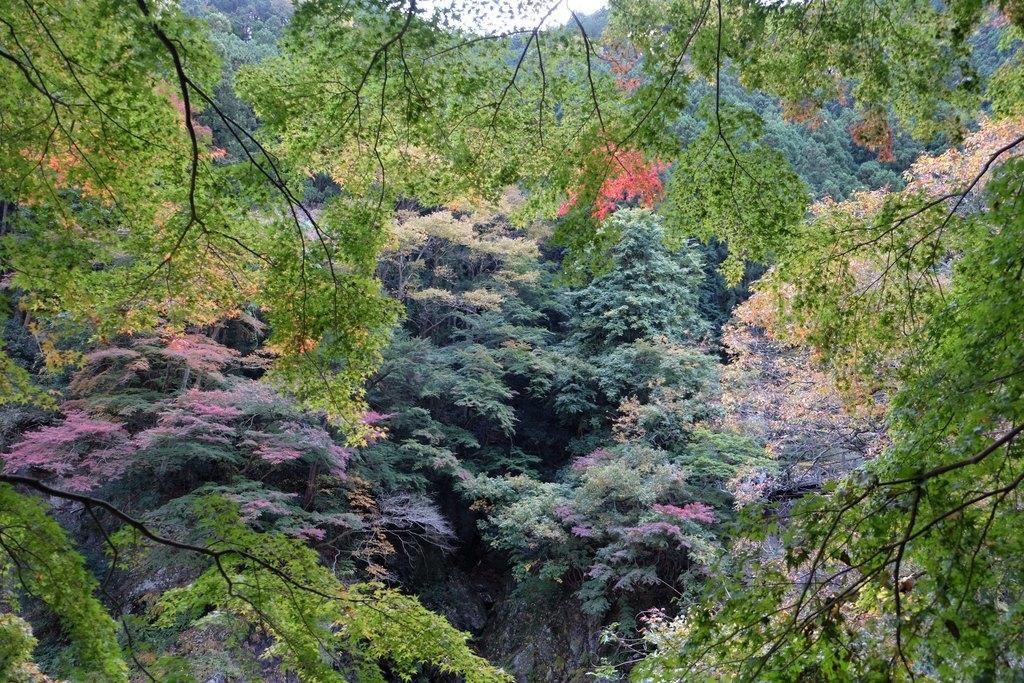Describe this image in one or two sentences. In this picture we can see some trees all over the image. 